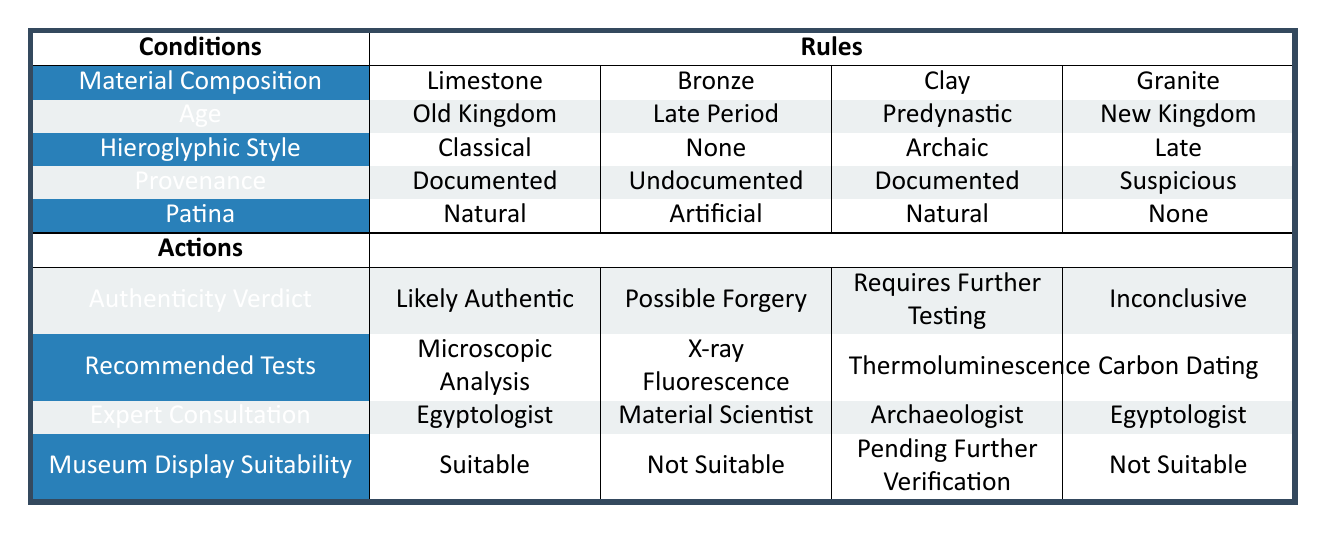What is the authenticity verdict for an artifact made of limestone from the Old Kingdom with a classical hieroglyphic style and documented provenance? According to the table, if the artifact is made of limestone, from the Old Kingdom, has a classical hieroglyphic style, and documented provenance, it falls under the first rule. The associated authenticity verdict is "Likely Authentic".
Answer: Likely Authentic Which recommended test is suggested for a bronze artifact from the Late Period with no hieroglyphic style and undocumented provenance? The second rule in the table states that for a bronze artifact from the Late Period with no hieroglyphic style and undocumented provenance, the recommended test is "X-ray Fluorescence".
Answer: X-ray Fluorescence Is the museum display suitability for a clay artifact from the Predynastic era with an archaic hieroglyphic style and natural patina considered suitable? The rules indicate that for a clay artifact from the Predynastic era with an archaic hieroglyphic style, documented provenance, and natural patina, the museum display suitability is "Pending Further Verification", which means it is not considered suitable.
Answer: No What is the difference in authenticity verdicts between a granite artifact from the New Kingdom with suspicious provenance and a bronze artifact from the Late Period with undocumented provenance? The granite artifact has an authenticity verdict of "Inconclusive", while the bronze artifact has an authenticity verdict of "Possible Forgery". Therefore, the difference is that one verdict is inconclusive and the other indicates a possible forgery.
Answer: One is inconclusive; the other is possible forgery For which artifact would an Egyptologist be consulted based on the table? According to the first rule for a limestone artifact from the Old Kingdom with a classical hieroglyphic style, documented provenance, and natural patina, an Egyptologist would be consulted. Additionally, the granite artifact from the New Kingdom also requires consultation with an Egyptologist due to its suspicious provenance.
Answer: For limestone and granite artifacts Which combination of age and patina results in a recommendation for thermoluminescence testing? The table shows that a clay artifact from the Predynastic age with a natural patina requires further testing, which specifically includes thermoluminescence. Other combinations do not provide this recommendation.
Answer: Clay from Predynastic with natural patina 